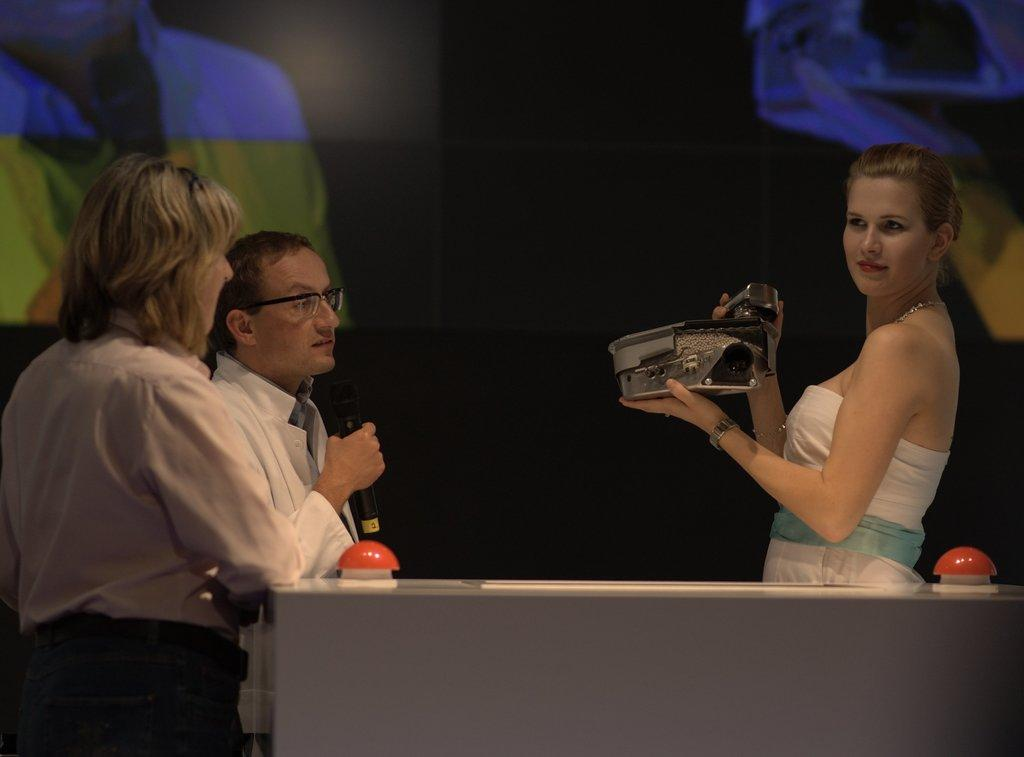How many people are in the image? There are three persons in the image. What is the man holding in the image? The man is holding a mic. What is the woman holding in the image? The woman is holding something. What can be seen in the background of the image? There is a screen visible in the background of the image. What type of flag is being waved by the woman in the image? There is no flag present in the image; the woman is holding something, but it is not a flag. Is there a quilt visible in the image? There is no quilt present in the image. 